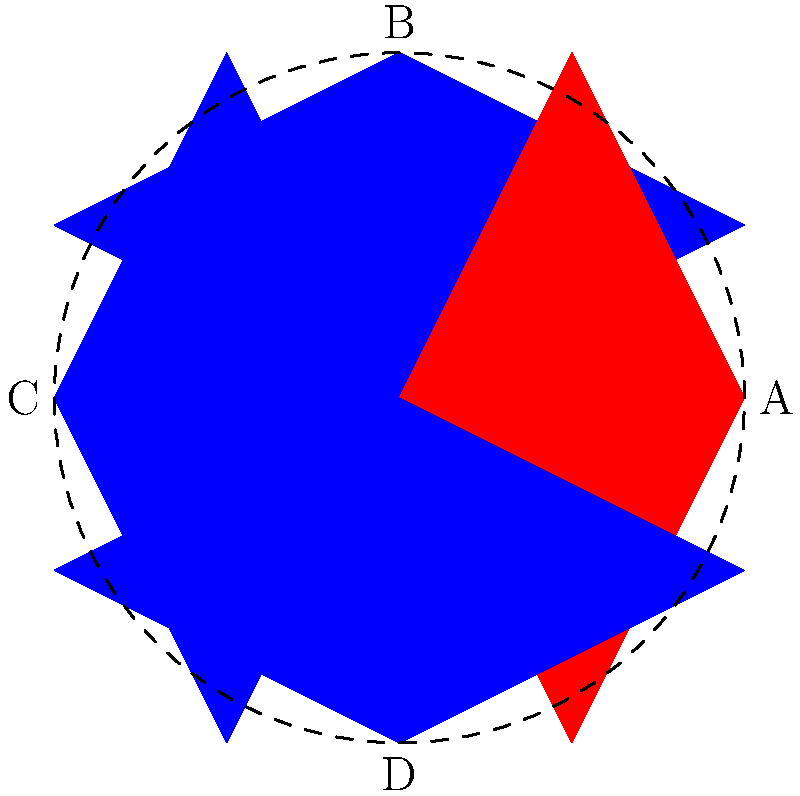In this traditional folk art design, a symmetrical flower pattern is created. How many lines of symmetry does this pattern have? To determine the number of lines of symmetry in this folk art design, we need to analyze the pattern carefully:

1. First, let's consider the vertical line passing through points B and D. If we fold the design along this line, the left half would perfectly match the right half. This is our first line of symmetry.

2. Next, let's look at the horizontal line passing through points A and C. Folding along this line would also result in a perfect match between the top and bottom halves. This is our second line of symmetry.

3. Now, let's consider the diagonal lines. There are two diagonal lines that pass through the center of the design:
   a. The line passing through the corners where the red and blue petals meet.
   b. The line passing through the points where the petals of the same color meet.

   Both of these diagonal lines also produce symmetrical halves when the design is folded along them.

4. Therefore, we have identified four lines of symmetry:
   - Vertical (B to D)
   - Horizontal (A to C)
   - Two diagonals

In total, this folk art design has 4 lines of symmetry.
Answer: 4 